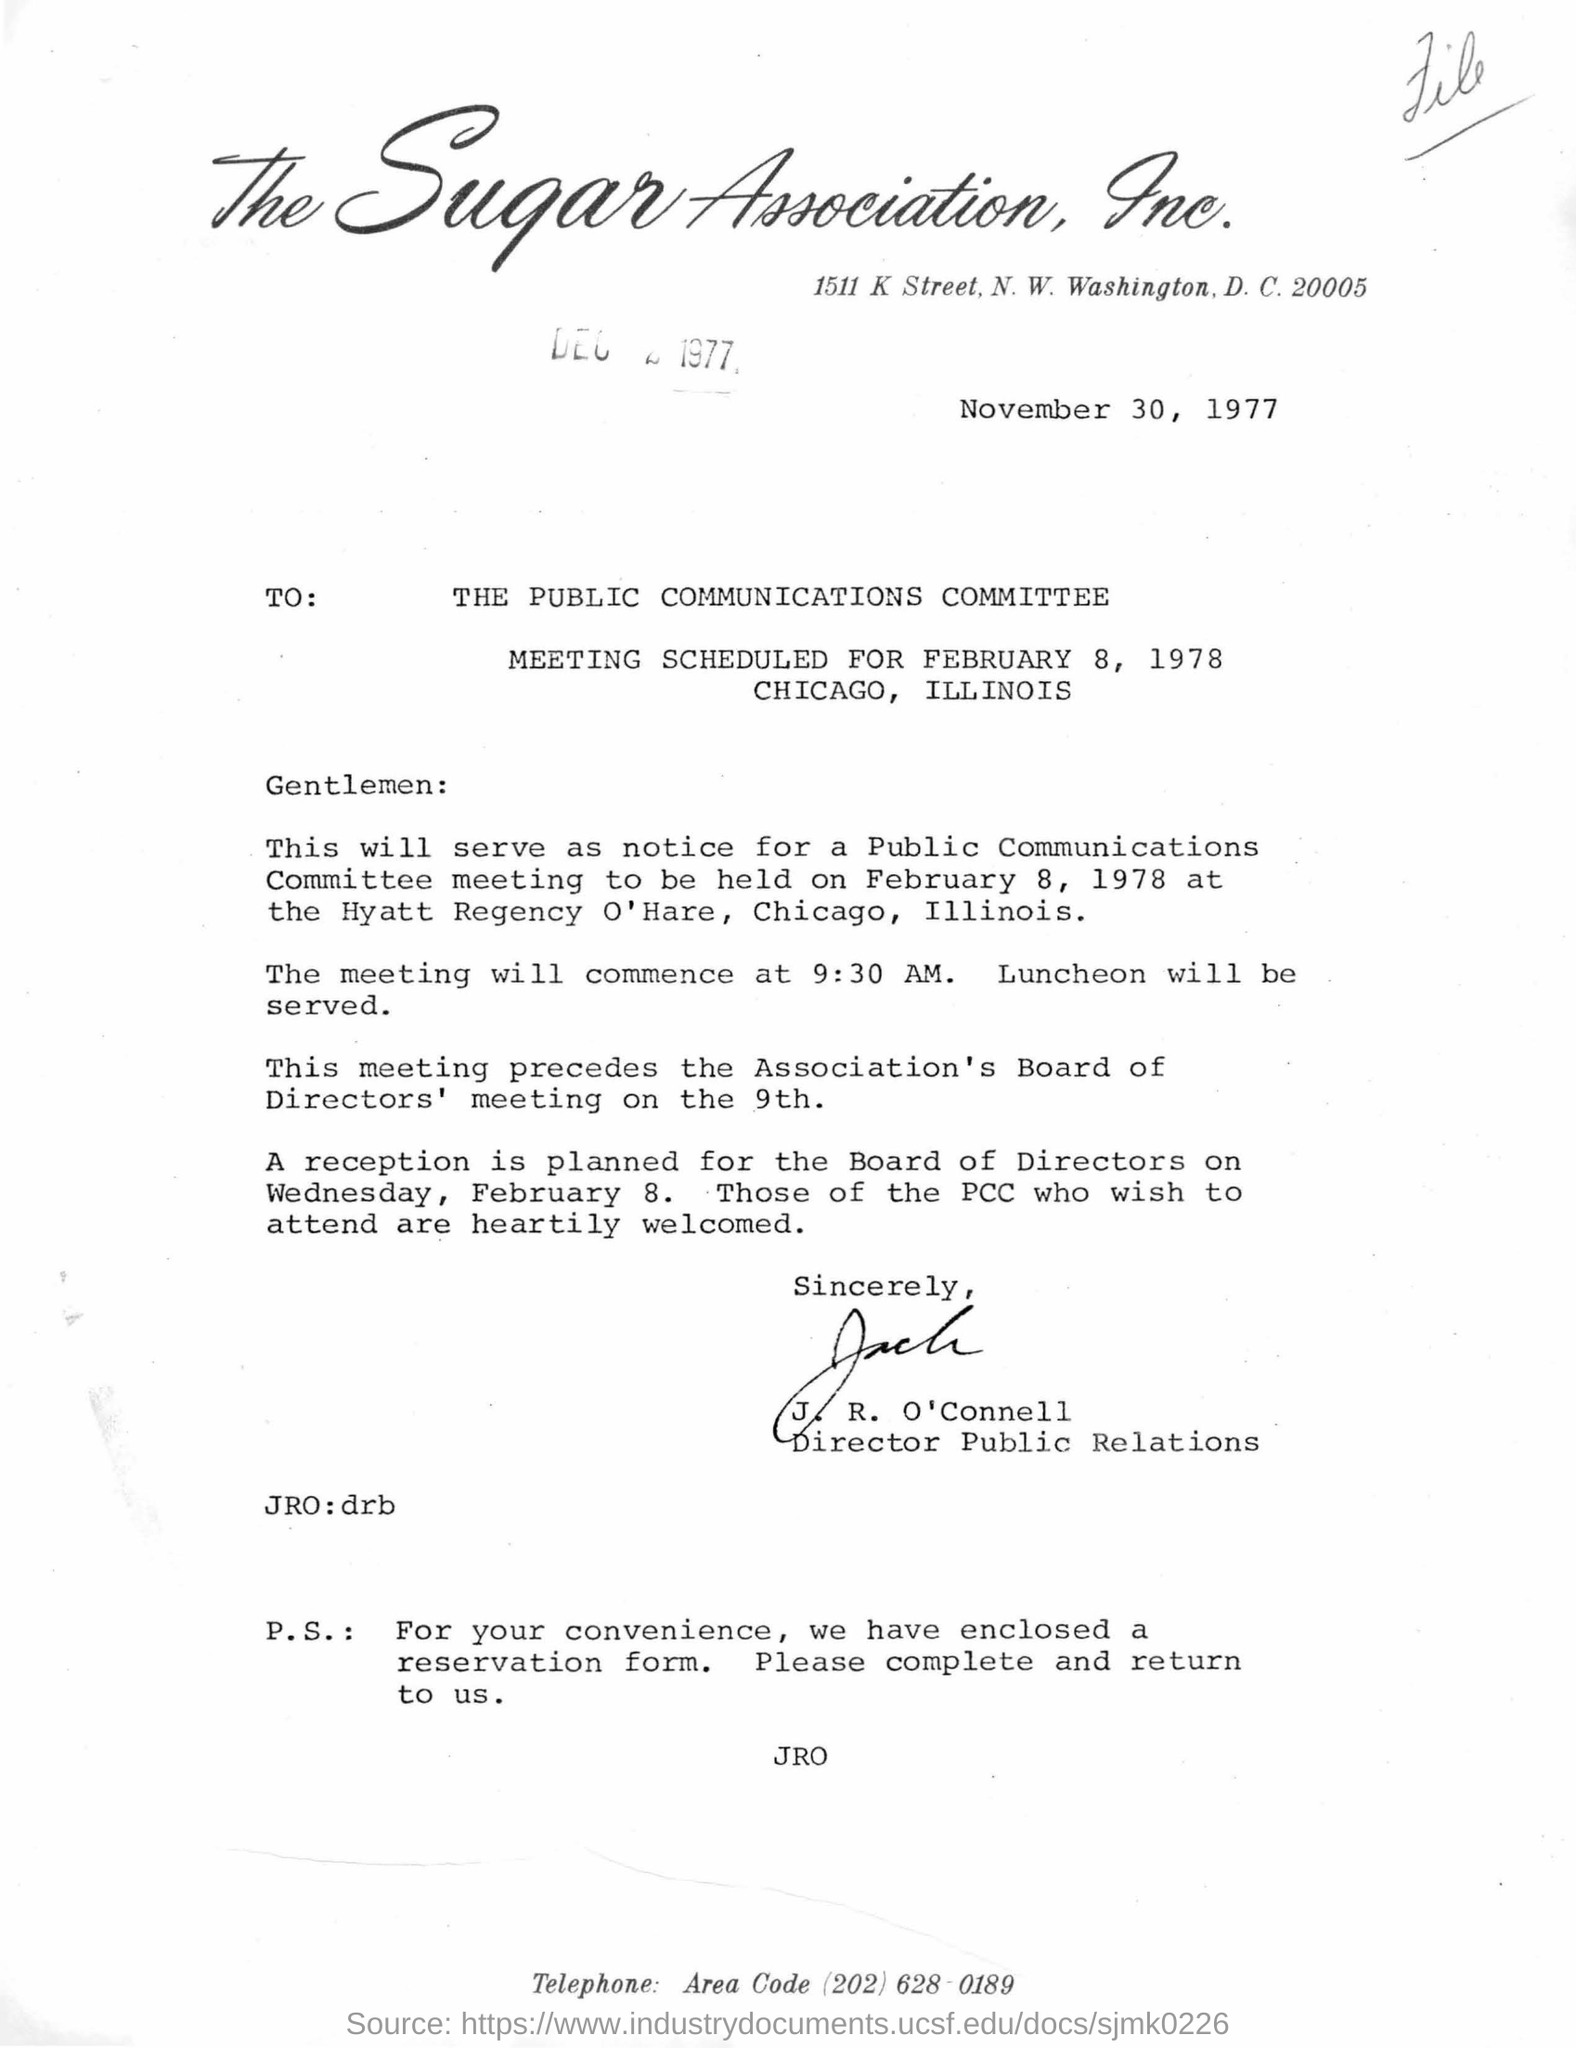Identify some key points in this picture. The meeting will commence at 9:30 AM on [date]. 